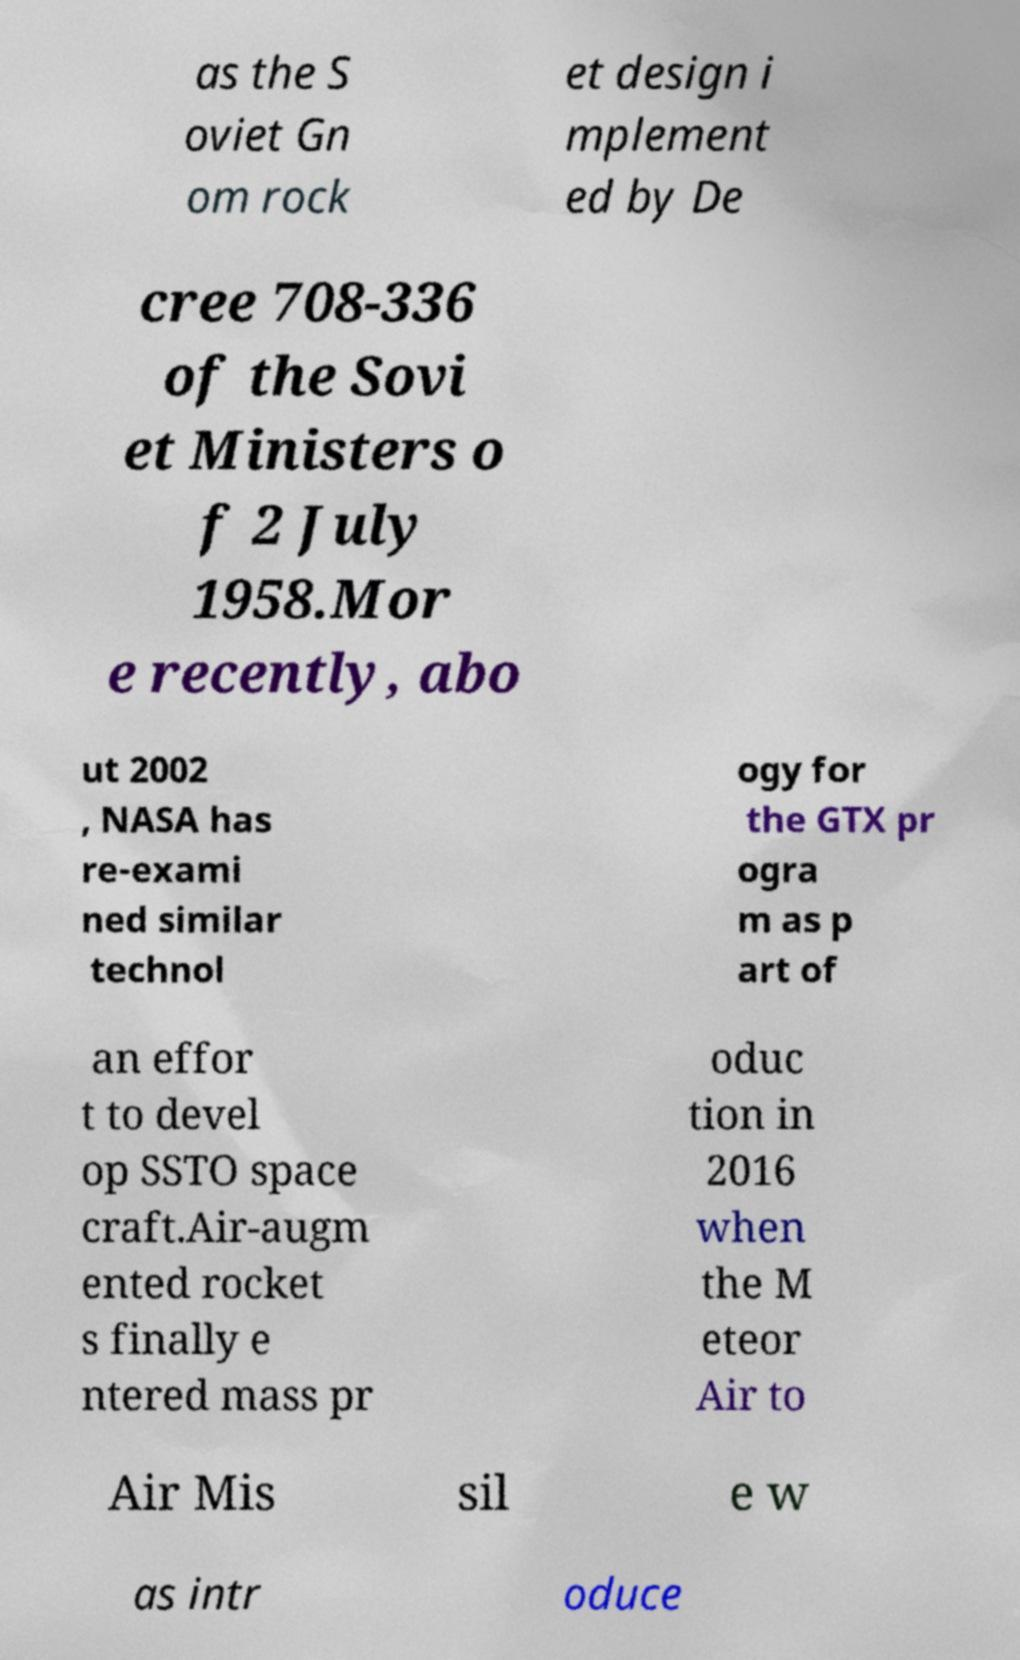I need the written content from this picture converted into text. Can you do that? as the S oviet Gn om rock et design i mplement ed by De cree 708-336 of the Sovi et Ministers o f 2 July 1958.Mor e recently, abo ut 2002 , NASA has re-exami ned similar technol ogy for the GTX pr ogra m as p art of an effor t to devel op SSTO space craft.Air-augm ented rocket s finally e ntered mass pr oduc tion in 2016 when the M eteor Air to Air Mis sil e w as intr oduce 